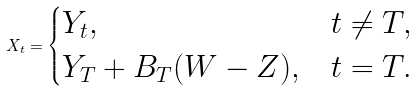<formula> <loc_0><loc_0><loc_500><loc_500>X _ { t } = \begin{cases} Y _ { t } , & t \neq T , \\ Y _ { T } + B _ { T } ( W - Z ) , & t = T . \end{cases}</formula> 